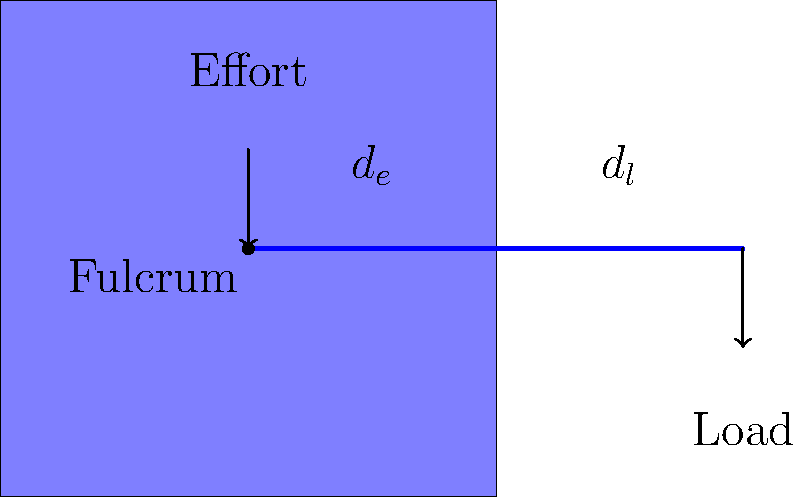In the ancient water-lifting device shown, the lever is used to raise water from a well. If the distance from the fulcrum to the effort ($d_e$) is 2 meters and the distance from the fulcrum to the load ($d_l$) is 0.5 meters, what is the mechanical advantage of this system? To find the mechanical advantage of this lever system, we need to follow these steps:

1. Recall the formula for mechanical advantage (MA) in a lever system:
   $$ MA = \frac{\text{distance to effort}}{\text{distance to load}} = \frac{d_e}{d_l} $$

2. Identify the given values:
   $d_e = 2$ meters
   $d_l = 0.5$ meters

3. Substitute these values into the formula:
   $$ MA = \frac{2 \text{ m}}{0.5 \text{ m}} $$

4. Perform the division:
   $$ MA = 4 $$

This means that the effort force is multiplied by a factor of 4, allowing the user to lift a load that is 4 times heavier than the effort they apply.
Answer: 4 